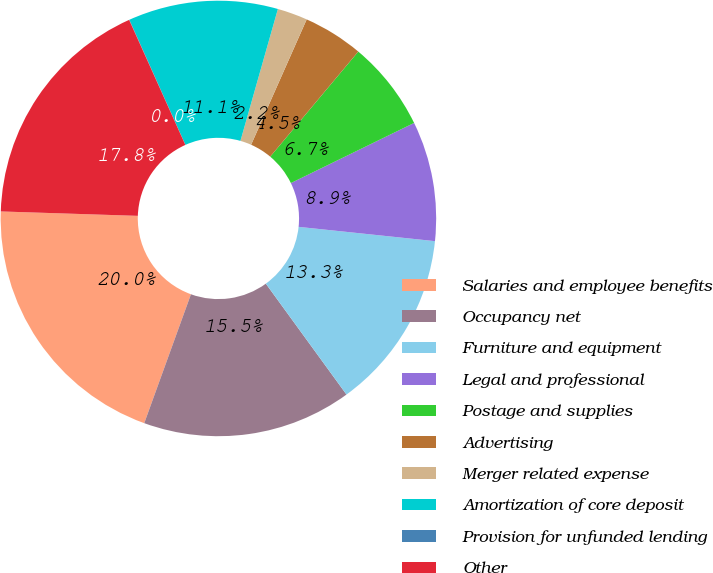<chart> <loc_0><loc_0><loc_500><loc_500><pie_chart><fcel>Salaries and employee benefits<fcel>Occupancy net<fcel>Furniture and equipment<fcel>Legal and professional<fcel>Postage and supplies<fcel>Advertising<fcel>Merger related expense<fcel>Amortization of core deposit<fcel>Provision for unfunded lending<fcel>Other<nl><fcel>19.98%<fcel>15.54%<fcel>13.33%<fcel>8.89%<fcel>6.67%<fcel>4.46%<fcel>2.24%<fcel>11.11%<fcel>0.02%<fcel>17.76%<nl></chart> 